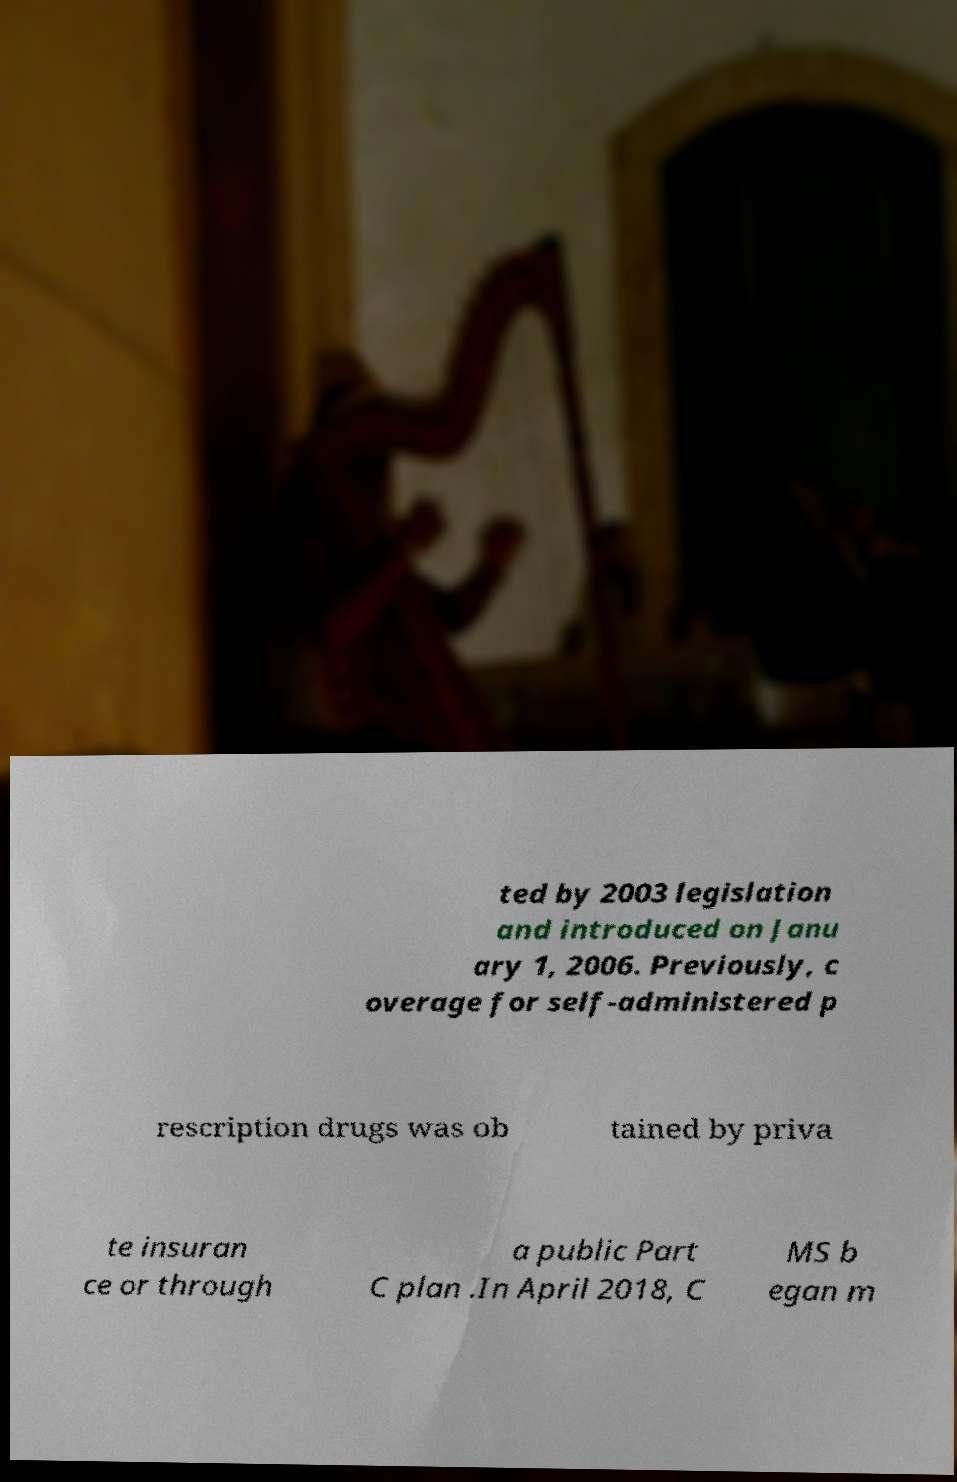Can you accurately transcribe the text from the provided image for me? ted by 2003 legislation and introduced on Janu ary 1, 2006. Previously, c overage for self-administered p rescription drugs was ob tained by priva te insuran ce or through a public Part C plan .In April 2018, C MS b egan m 